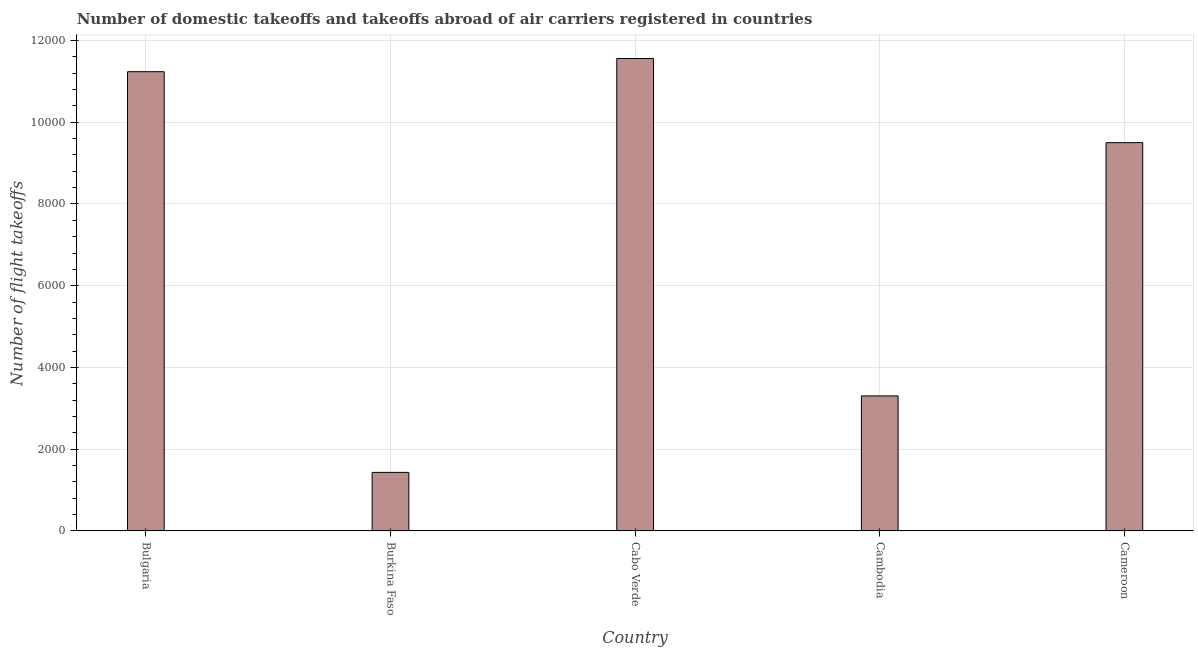Does the graph contain any zero values?
Your answer should be compact. No. What is the title of the graph?
Your answer should be very brief. Number of domestic takeoffs and takeoffs abroad of air carriers registered in countries. What is the label or title of the Y-axis?
Your response must be concise. Number of flight takeoffs. What is the number of flight takeoffs in Burkina Faso?
Your response must be concise. 1433. Across all countries, what is the maximum number of flight takeoffs?
Ensure brevity in your answer.  1.16e+04. Across all countries, what is the minimum number of flight takeoffs?
Your response must be concise. 1433. In which country was the number of flight takeoffs maximum?
Your answer should be compact. Cabo Verde. In which country was the number of flight takeoffs minimum?
Provide a succinct answer. Burkina Faso. What is the sum of the number of flight takeoffs?
Provide a short and direct response. 3.70e+04. What is the difference between the number of flight takeoffs in Burkina Faso and Cambodia?
Your response must be concise. -1871. What is the average number of flight takeoffs per country?
Offer a terse response. 7407. What is the median number of flight takeoffs?
Your answer should be very brief. 9501. What is the ratio of the number of flight takeoffs in Cabo Verde to that in Cambodia?
Keep it short and to the point. 3.5. Is the difference between the number of flight takeoffs in Bulgaria and Burkina Faso greater than the difference between any two countries?
Your response must be concise. No. What is the difference between the highest and the second highest number of flight takeoffs?
Provide a succinct answer. 323. What is the difference between the highest and the lowest number of flight takeoffs?
Your response must be concise. 1.01e+04. In how many countries, is the number of flight takeoffs greater than the average number of flight takeoffs taken over all countries?
Offer a terse response. 3. How many countries are there in the graph?
Give a very brief answer. 5. Are the values on the major ticks of Y-axis written in scientific E-notation?
Provide a short and direct response. No. What is the Number of flight takeoffs in Bulgaria?
Offer a terse response. 1.12e+04. What is the Number of flight takeoffs in Burkina Faso?
Your answer should be very brief. 1433. What is the Number of flight takeoffs of Cabo Verde?
Your response must be concise. 1.16e+04. What is the Number of flight takeoffs of Cambodia?
Your answer should be compact. 3304. What is the Number of flight takeoffs in Cameroon?
Your answer should be very brief. 9501. What is the difference between the Number of flight takeoffs in Bulgaria and Burkina Faso?
Provide a short and direct response. 9804. What is the difference between the Number of flight takeoffs in Bulgaria and Cabo Verde?
Provide a short and direct response. -323. What is the difference between the Number of flight takeoffs in Bulgaria and Cambodia?
Offer a very short reply. 7933. What is the difference between the Number of flight takeoffs in Bulgaria and Cameroon?
Your response must be concise. 1736. What is the difference between the Number of flight takeoffs in Burkina Faso and Cabo Verde?
Provide a succinct answer. -1.01e+04. What is the difference between the Number of flight takeoffs in Burkina Faso and Cambodia?
Offer a very short reply. -1871. What is the difference between the Number of flight takeoffs in Burkina Faso and Cameroon?
Make the answer very short. -8068. What is the difference between the Number of flight takeoffs in Cabo Verde and Cambodia?
Your answer should be very brief. 8256. What is the difference between the Number of flight takeoffs in Cabo Verde and Cameroon?
Provide a short and direct response. 2059. What is the difference between the Number of flight takeoffs in Cambodia and Cameroon?
Your answer should be very brief. -6197. What is the ratio of the Number of flight takeoffs in Bulgaria to that in Burkina Faso?
Make the answer very short. 7.84. What is the ratio of the Number of flight takeoffs in Bulgaria to that in Cambodia?
Keep it short and to the point. 3.4. What is the ratio of the Number of flight takeoffs in Bulgaria to that in Cameroon?
Provide a succinct answer. 1.18. What is the ratio of the Number of flight takeoffs in Burkina Faso to that in Cabo Verde?
Offer a terse response. 0.12. What is the ratio of the Number of flight takeoffs in Burkina Faso to that in Cambodia?
Make the answer very short. 0.43. What is the ratio of the Number of flight takeoffs in Burkina Faso to that in Cameroon?
Ensure brevity in your answer.  0.15. What is the ratio of the Number of flight takeoffs in Cabo Verde to that in Cambodia?
Provide a short and direct response. 3.5. What is the ratio of the Number of flight takeoffs in Cabo Verde to that in Cameroon?
Your answer should be compact. 1.22. What is the ratio of the Number of flight takeoffs in Cambodia to that in Cameroon?
Keep it short and to the point. 0.35. 